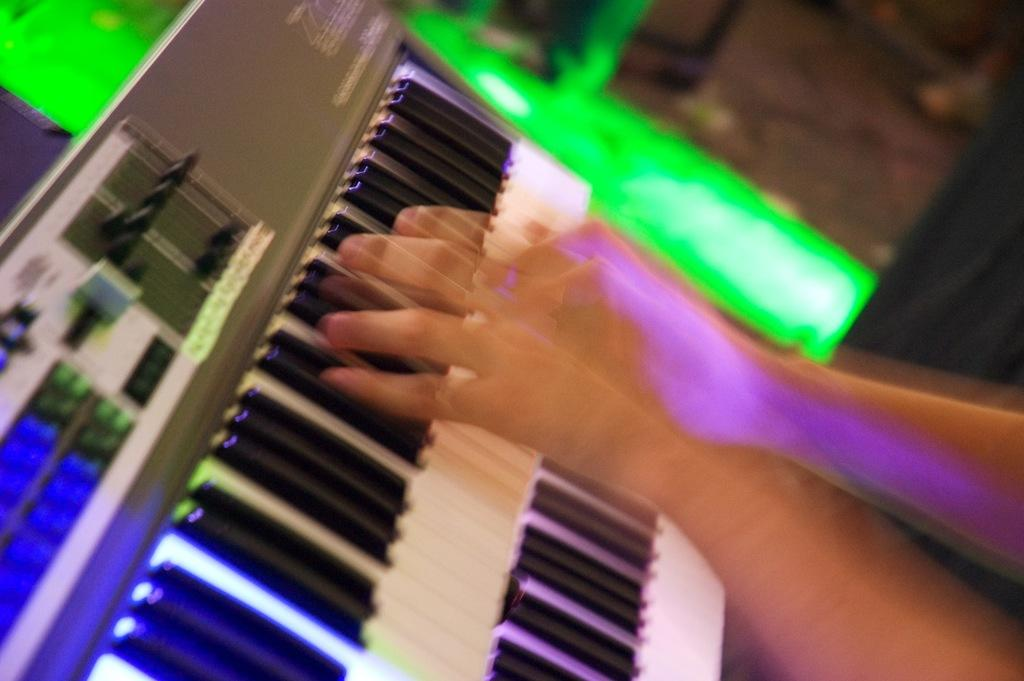What is the person in the image doing with their hands? The person's hands are playing a piano in the image. What type of musical instrument is being played? The object being played is a keyboard. Can you describe the background of the image? The background of the image appears blurry. What type of stamp can be seen on the chicken's beak in the image? There is no chicken or stamp present in the image; it features a person playing a keyboard. What role does the fireman play in the image? There is no fireman present in the image; it features a person playing a keyboard. 